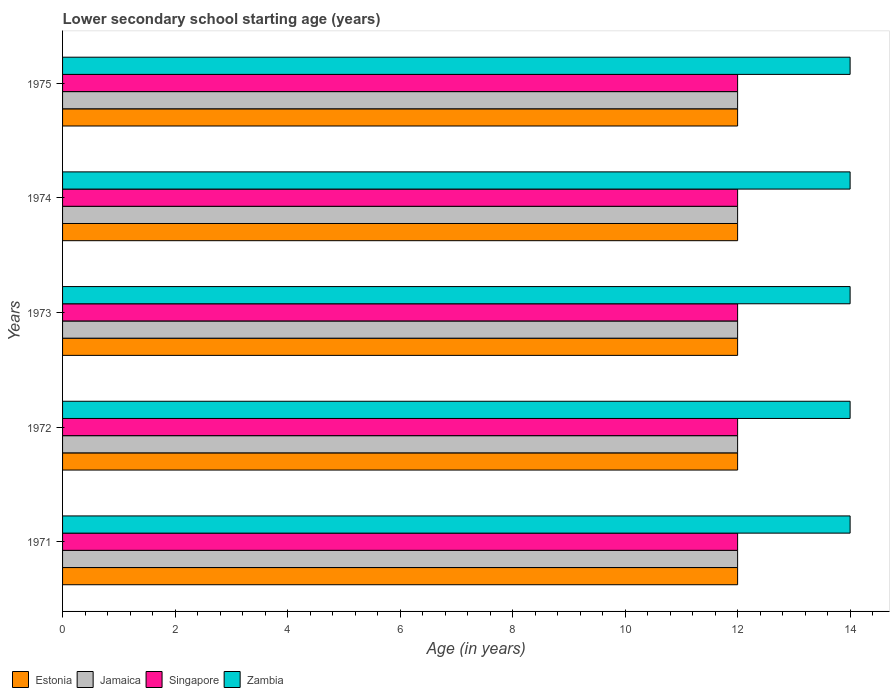Are the number of bars on each tick of the Y-axis equal?
Ensure brevity in your answer.  Yes. What is the label of the 2nd group of bars from the top?
Your answer should be compact. 1974. What is the lower secondary school starting age of children in Singapore in 1975?
Your response must be concise. 12. Across all years, what is the maximum lower secondary school starting age of children in Zambia?
Offer a very short reply. 14. Across all years, what is the minimum lower secondary school starting age of children in Singapore?
Give a very brief answer. 12. In which year was the lower secondary school starting age of children in Zambia maximum?
Offer a very short reply. 1971. In which year was the lower secondary school starting age of children in Singapore minimum?
Give a very brief answer. 1971. What is the total lower secondary school starting age of children in Singapore in the graph?
Make the answer very short. 60. What is the difference between the lower secondary school starting age of children in Jamaica in 1971 and the lower secondary school starting age of children in Estonia in 1975?
Offer a very short reply. 0. What is the average lower secondary school starting age of children in Zambia per year?
Provide a short and direct response. 14. In the year 1972, what is the difference between the lower secondary school starting age of children in Zambia and lower secondary school starting age of children in Singapore?
Ensure brevity in your answer.  2. What is the difference between the highest and the second highest lower secondary school starting age of children in Jamaica?
Offer a very short reply. 0. Is it the case that in every year, the sum of the lower secondary school starting age of children in Singapore and lower secondary school starting age of children in Jamaica is greater than the sum of lower secondary school starting age of children in Estonia and lower secondary school starting age of children in Zambia?
Provide a short and direct response. No. What does the 3rd bar from the top in 1974 represents?
Offer a very short reply. Jamaica. What does the 1st bar from the bottom in 1973 represents?
Ensure brevity in your answer.  Estonia. How many bars are there?
Give a very brief answer. 20. What is the difference between two consecutive major ticks on the X-axis?
Your answer should be very brief. 2. Are the values on the major ticks of X-axis written in scientific E-notation?
Your answer should be very brief. No. How many legend labels are there?
Keep it short and to the point. 4. How are the legend labels stacked?
Offer a terse response. Horizontal. What is the title of the graph?
Provide a succinct answer. Lower secondary school starting age (years). Does "Vanuatu" appear as one of the legend labels in the graph?
Make the answer very short. No. What is the label or title of the X-axis?
Offer a very short reply. Age (in years). What is the label or title of the Y-axis?
Your answer should be very brief. Years. What is the Age (in years) of Jamaica in 1971?
Offer a terse response. 12. What is the Age (in years) in Zambia in 1971?
Give a very brief answer. 14. What is the Age (in years) in Estonia in 1972?
Your answer should be compact. 12. What is the Age (in years) in Singapore in 1972?
Provide a short and direct response. 12. What is the Age (in years) in Zambia in 1972?
Your answer should be very brief. 14. What is the Age (in years) of Estonia in 1973?
Provide a short and direct response. 12. What is the Age (in years) of Zambia in 1973?
Offer a very short reply. 14. What is the Age (in years) of Estonia in 1974?
Your response must be concise. 12. What is the Age (in years) of Singapore in 1974?
Your answer should be very brief. 12. What is the Age (in years) of Zambia in 1974?
Provide a succinct answer. 14. Across all years, what is the maximum Age (in years) in Estonia?
Provide a short and direct response. 12. Across all years, what is the minimum Age (in years) in Estonia?
Provide a succinct answer. 12. What is the total Age (in years) of Jamaica in the graph?
Your answer should be compact. 60. What is the difference between the Age (in years) of Estonia in 1971 and that in 1972?
Offer a very short reply. 0. What is the difference between the Age (in years) in Jamaica in 1971 and that in 1972?
Make the answer very short. 0. What is the difference between the Age (in years) of Zambia in 1971 and that in 1973?
Your response must be concise. 0. What is the difference between the Age (in years) of Jamaica in 1971 and that in 1974?
Provide a short and direct response. 0. What is the difference between the Age (in years) in Estonia in 1971 and that in 1975?
Keep it short and to the point. 0. What is the difference between the Age (in years) in Singapore in 1971 and that in 1975?
Ensure brevity in your answer.  0. What is the difference between the Age (in years) in Zambia in 1971 and that in 1975?
Make the answer very short. 0. What is the difference between the Age (in years) in Estonia in 1972 and that in 1973?
Offer a terse response. 0. What is the difference between the Age (in years) in Estonia in 1972 and that in 1974?
Offer a very short reply. 0. What is the difference between the Age (in years) of Jamaica in 1972 and that in 1974?
Offer a terse response. 0. What is the difference between the Age (in years) of Jamaica in 1972 and that in 1975?
Offer a terse response. 0. What is the difference between the Age (in years) of Estonia in 1973 and that in 1974?
Offer a terse response. 0. What is the difference between the Age (in years) of Zambia in 1973 and that in 1974?
Give a very brief answer. 0. What is the difference between the Age (in years) in Jamaica in 1973 and that in 1975?
Provide a succinct answer. 0. What is the difference between the Age (in years) in Singapore in 1973 and that in 1975?
Give a very brief answer. 0. What is the difference between the Age (in years) in Zambia in 1973 and that in 1975?
Your answer should be compact. 0. What is the difference between the Age (in years) of Zambia in 1974 and that in 1975?
Offer a very short reply. 0. What is the difference between the Age (in years) in Estonia in 1971 and the Age (in years) in Singapore in 1972?
Give a very brief answer. 0. What is the difference between the Age (in years) of Estonia in 1971 and the Age (in years) of Zambia in 1972?
Make the answer very short. -2. What is the difference between the Age (in years) of Jamaica in 1971 and the Age (in years) of Singapore in 1972?
Ensure brevity in your answer.  0. What is the difference between the Age (in years) of Jamaica in 1971 and the Age (in years) of Zambia in 1972?
Ensure brevity in your answer.  -2. What is the difference between the Age (in years) in Singapore in 1971 and the Age (in years) in Zambia in 1972?
Provide a succinct answer. -2. What is the difference between the Age (in years) of Estonia in 1971 and the Age (in years) of Jamaica in 1973?
Provide a short and direct response. 0. What is the difference between the Age (in years) of Estonia in 1971 and the Age (in years) of Singapore in 1973?
Make the answer very short. 0. What is the difference between the Age (in years) of Jamaica in 1971 and the Age (in years) of Zambia in 1973?
Your response must be concise. -2. What is the difference between the Age (in years) in Estonia in 1971 and the Age (in years) in Jamaica in 1974?
Ensure brevity in your answer.  0. What is the difference between the Age (in years) in Singapore in 1971 and the Age (in years) in Zambia in 1974?
Provide a succinct answer. -2. What is the difference between the Age (in years) in Estonia in 1971 and the Age (in years) in Jamaica in 1975?
Your response must be concise. 0. What is the difference between the Age (in years) in Estonia in 1972 and the Age (in years) in Zambia in 1973?
Provide a succinct answer. -2. What is the difference between the Age (in years) in Jamaica in 1972 and the Age (in years) in Singapore in 1973?
Your response must be concise. 0. What is the difference between the Age (in years) of Singapore in 1972 and the Age (in years) of Zambia in 1973?
Your answer should be very brief. -2. What is the difference between the Age (in years) in Estonia in 1972 and the Age (in years) in Jamaica in 1974?
Ensure brevity in your answer.  0. What is the difference between the Age (in years) of Estonia in 1972 and the Age (in years) of Zambia in 1974?
Offer a terse response. -2. What is the difference between the Age (in years) of Jamaica in 1972 and the Age (in years) of Singapore in 1974?
Offer a very short reply. 0. What is the difference between the Age (in years) in Jamaica in 1972 and the Age (in years) in Zambia in 1974?
Offer a terse response. -2. What is the difference between the Age (in years) of Jamaica in 1972 and the Age (in years) of Singapore in 1975?
Offer a very short reply. 0. What is the difference between the Age (in years) of Jamaica in 1972 and the Age (in years) of Zambia in 1975?
Keep it short and to the point. -2. What is the difference between the Age (in years) in Singapore in 1972 and the Age (in years) in Zambia in 1975?
Provide a succinct answer. -2. What is the difference between the Age (in years) of Jamaica in 1973 and the Age (in years) of Singapore in 1974?
Your answer should be very brief. 0. What is the difference between the Age (in years) of Jamaica in 1973 and the Age (in years) of Zambia in 1974?
Your response must be concise. -2. What is the difference between the Age (in years) of Estonia in 1973 and the Age (in years) of Zambia in 1975?
Your answer should be compact. -2. What is the difference between the Age (in years) in Jamaica in 1973 and the Age (in years) in Zambia in 1975?
Provide a short and direct response. -2. What is the difference between the Age (in years) in Estonia in 1974 and the Age (in years) in Jamaica in 1975?
Your answer should be compact. 0. What is the difference between the Age (in years) of Estonia in 1974 and the Age (in years) of Singapore in 1975?
Your response must be concise. 0. What is the difference between the Age (in years) of Estonia in 1974 and the Age (in years) of Zambia in 1975?
Provide a succinct answer. -2. In the year 1971, what is the difference between the Age (in years) in Estonia and Age (in years) in Jamaica?
Ensure brevity in your answer.  0. In the year 1971, what is the difference between the Age (in years) of Estonia and Age (in years) of Zambia?
Keep it short and to the point. -2. In the year 1971, what is the difference between the Age (in years) in Jamaica and Age (in years) in Zambia?
Provide a short and direct response. -2. In the year 1972, what is the difference between the Age (in years) in Estonia and Age (in years) in Jamaica?
Your answer should be very brief. 0. In the year 1972, what is the difference between the Age (in years) of Estonia and Age (in years) of Zambia?
Your response must be concise. -2. In the year 1973, what is the difference between the Age (in years) of Jamaica and Age (in years) of Zambia?
Offer a terse response. -2. In the year 1974, what is the difference between the Age (in years) in Estonia and Age (in years) in Jamaica?
Provide a short and direct response. 0. In the year 1974, what is the difference between the Age (in years) of Estonia and Age (in years) of Zambia?
Make the answer very short. -2. In the year 1975, what is the difference between the Age (in years) in Jamaica and Age (in years) in Singapore?
Your answer should be very brief. 0. In the year 1975, what is the difference between the Age (in years) of Jamaica and Age (in years) of Zambia?
Provide a short and direct response. -2. In the year 1975, what is the difference between the Age (in years) in Singapore and Age (in years) in Zambia?
Provide a short and direct response. -2. What is the ratio of the Age (in years) in Estonia in 1971 to that in 1972?
Make the answer very short. 1. What is the ratio of the Age (in years) in Jamaica in 1971 to that in 1973?
Offer a very short reply. 1. What is the ratio of the Age (in years) in Singapore in 1971 to that in 1973?
Provide a short and direct response. 1. What is the ratio of the Age (in years) in Zambia in 1971 to that in 1973?
Offer a very short reply. 1. What is the ratio of the Age (in years) in Jamaica in 1971 to that in 1974?
Provide a short and direct response. 1. What is the ratio of the Age (in years) of Estonia in 1971 to that in 1975?
Make the answer very short. 1. What is the ratio of the Age (in years) of Jamaica in 1971 to that in 1975?
Provide a succinct answer. 1. What is the ratio of the Age (in years) of Estonia in 1972 to that in 1974?
Your answer should be very brief. 1. What is the ratio of the Age (in years) in Jamaica in 1972 to that in 1974?
Ensure brevity in your answer.  1. What is the ratio of the Age (in years) of Singapore in 1972 to that in 1974?
Provide a succinct answer. 1. What is the ratio of the Age (in years) in Zambia in 1972 to that in 1974?
Your answer should be compact. 1. What is the ratio of the Age (in years) of Estonia in 1972 to that in 1975?
Give a very brief answer. 1. What is the ratio of the Age (in years) in Jamaica in 1972 to that in 1975?
Offer a very short reply. 1. What is the ratio of the Age (in years) in Zambia in 1972 to that in 1975?
Your answer should be very brief. 1. What is the ratio of the Age (in years) of Estonia in 1973 to that in 1974?
Your answer should be compact. 1. What is the ratio of the Age (in years) in Zambia in 1973 to that in 1975?
Keep it short and to the point. 1. What is the ratio of the Age (in years) in Jamaica in 1974 to that in 1975?
Your answer should be compact. 1. What is the difference between the highest and the second highest Age (in years) in Jamaica?
Your answer should be very brief. 0. What is the difference between the highest and the lowest Age (in years) in Estonia?
Offer a terse response. 0. What is the difference between the highest and the lowest Age (in years) in Jamaica?
Give a very brief answer. 0. What is the difference between the highest and the lowest Age (in years) in Singapore?
Your response must be concise. 0. 